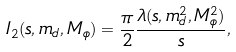<formula> <loc_0><loc_0><loc_500><loc_500>I _ { 2 } ( s , m _ { d } , M _ { \phi } ) = \frac { \pi } { 2 } \frac { \lambda ( s , m _ { d } ^ { 2 } , M _ { \phi } ^ { 2 } ) } { s } ,</formula> 